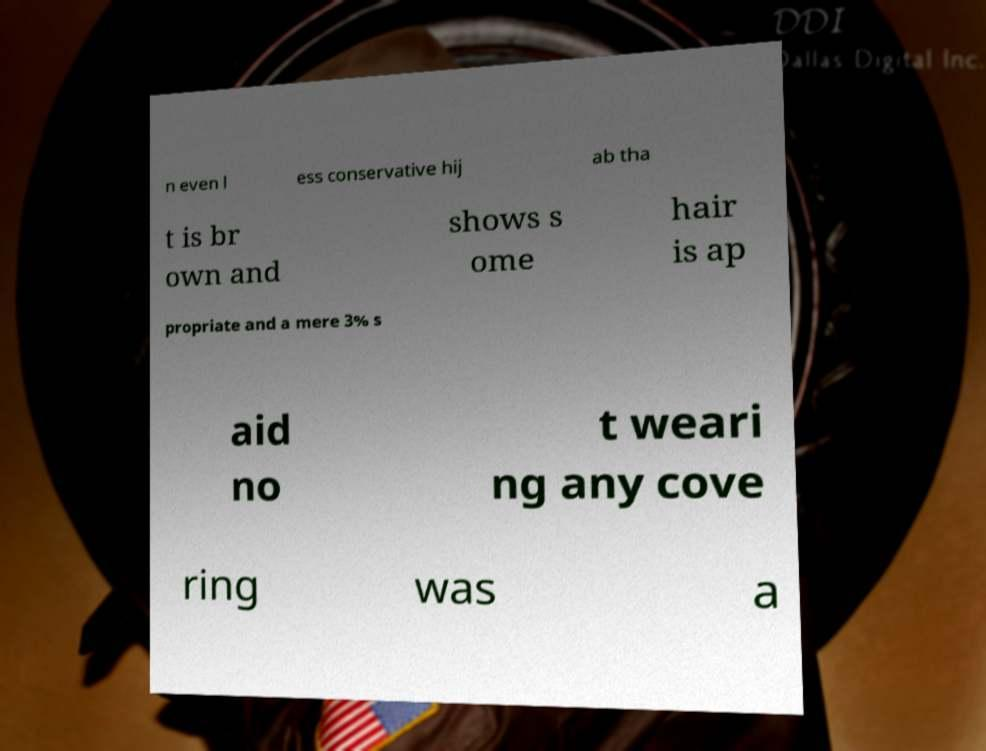Please identify and transcribe the text found in this image. n even l ess conservative hij ab tha t is br own and shows s ome hair is ap propriate and a mere 3% s aid no t weari ng any cove ring was a 